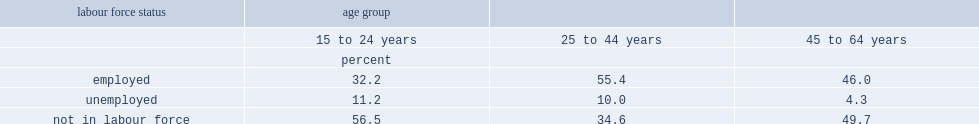What is the percentage of 15- to 24-year-old people with disabilities reporting that they were employed? 32.2. What is the percentage of people at ages 25 to 44 years with disabilities reporting that they were employed? 55.4. What is the percentage of people at ages 45 to 64 years with disabilities reporting that they were employed? 46.0. What is the percentage not in the labour force at ages 25 to 44 years? 34.6. What is the percentage not in the labour force at ages 45 to 64 years? 49.7. 